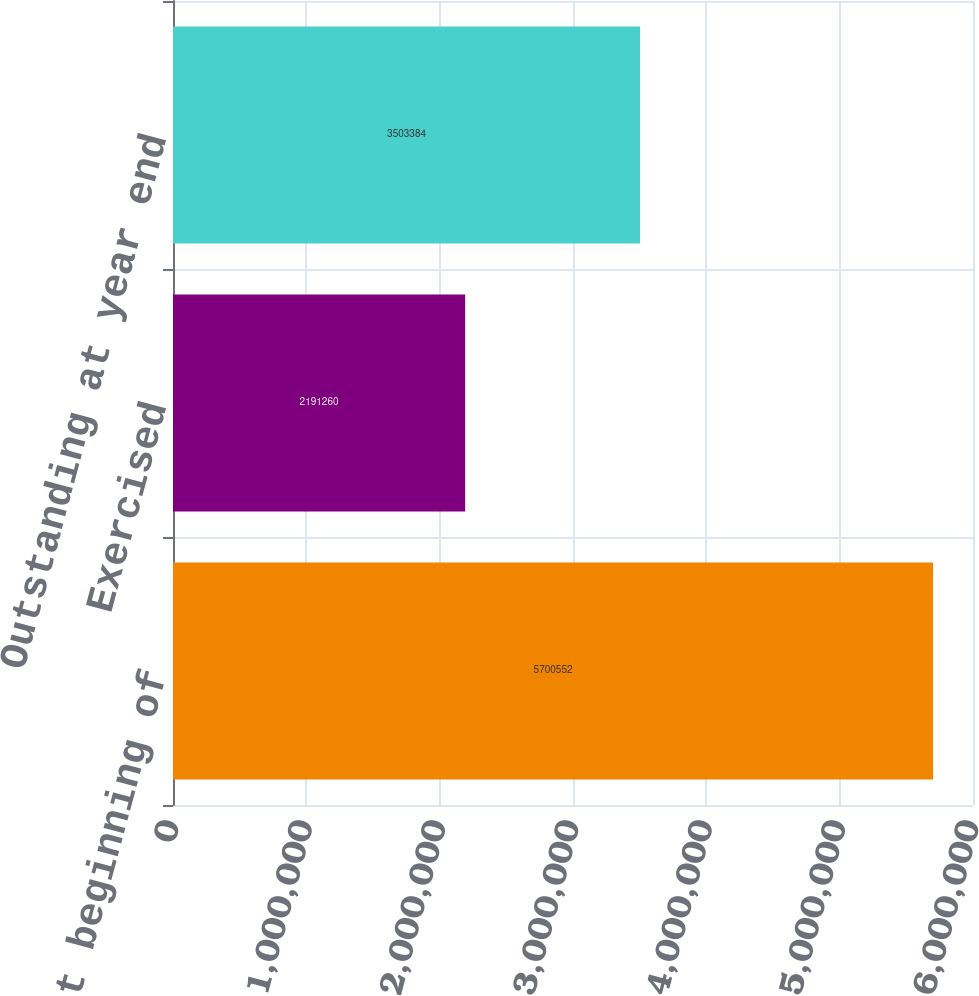Convert chart to OTSL. <chart><loc_0><loc_0><loc_500><loc_500><bar_chart><fcel>Outstanding at beginning of<fcel>Exercised<fcel>Outstanding at year end<nl><fcel>5.70055e+06<fcel>2.19126e+06<fcel>3.50338e+06<nl></chart> 